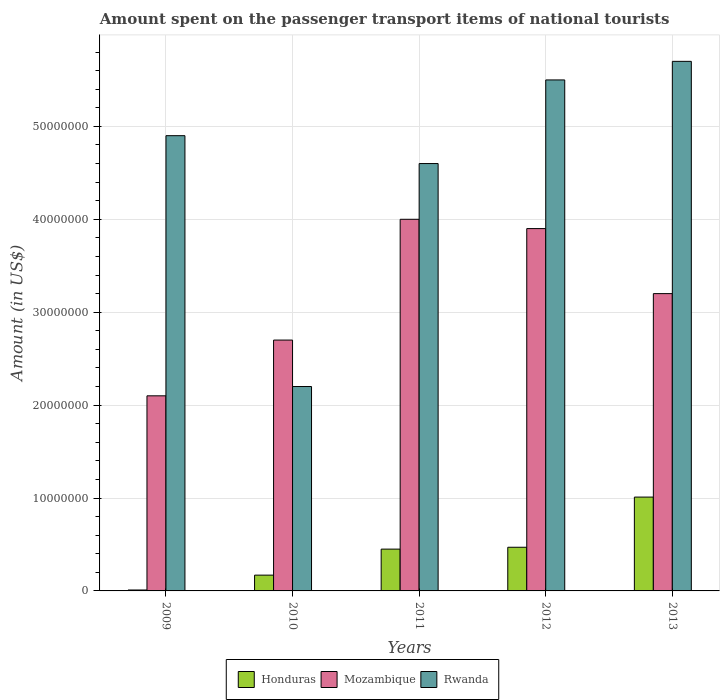How many different coloured bars are there?
Offer a terse response. 3. How many groups of bars are there?
Give a very brief answer. 5. Are the number of bars per tick equal to the number of legend labels?
Give a very brief answer. Yes. In how many cases, is the number of bars for a given year not equal to the number of legend labels?
Ensure brevity in your answer.  0. What is the amount spent on the passenger transport items of national tourists in Mozambique in 2011?
Offer a very short reply. 4.00e+07. Across all years, what is the maximum amount spent on the passenger transport items of national tourists in Mozambique?
Offer a very short reply. 4.00e+07. Across all years, what is the minimum amount spent on the passenger transport items of national tourists in Honduras?
Provide a short and direct response. 1.00e+05. What is the total amount spent on the passenger transport items of national tourists in Rwanda in the graph?
Offer a terse response. 2.29e+08. What is the difference between the amount spent on the passenger transport items of national tourists in Honduras in 2009 and that in 2010?
Ensure brevity in your answer.  -1.60e+06. What is the average amount spent on the passenger transport items of national tourists in Rwanda per year?
Your answer should be compact. 4.58e+07. In the year 2009, what is the difference between the amount spent on the passenger transport items of national tourists in Mozambique and amount spent on the passenger transport items of national tourists in Rwanda?
Your answer should be compact. -2.80e+07. What is the ratio of the amount spent on the passenger transport items of national tourists in Honduras in 2011 to that in 2012?
Give a very brief answer. 0.96. Is the amount spent on the passenger transport items of national tourists in Mozambique in 2010 less than that in 2011?
Your response must be concise. Yes. Is the difference between the amount spent on the passenger transport items of national tourists in Mozambique in 2009 and 2010 greater than the difference between the amount spent on the passenger transport items of national tourists in Rwanda in 2009 and 2010?
Your answer should be compact. No. What is the difference between the highest and the second highest amount spent on the passenger transport items of national tourists in Rwanda?
Your response must be concise. 2.00e+06. What is the difference between the highest and the lowest amount spent on the passenger transport items of national tourists in Rwanda?
Provide a short and direct response. 3.50e+07. In how many years, is the amount spent on the passenger transport items of national tourists in Honduras greater than the average amount spent on the passenger transport items of national tourists in Honduras taken over all years?
Offer a terse response. 3. What does the 3rd bar from the left in 2012 represents?
Offer a terse response. Rwanda. What does the 3rd bar from the right in 2011 represents?
Provide a short and direct response. Honduras. Is it the case that in every year, the sum of the amount spent on the passenger transport items of national tourists in Honduras and amount spent on the passenger transport items of national tourists in Rwanda is greater than the amount spent on the passenger transport items of national tourists in Mozambique?
Make the answer very short. No. What is the difference between two consecutive major ticks on the Y-axis?
Your answer should be compact. 1.00e+07. Are the values on the major ticks of Y-axis written in scientific E-notation?
Keep it short and to the point. No. What is the title of the graph?
Make the answer very short. Amount spent on the passenger transport items of national tourists. What is the label or title of the X-axis?
Your response must be concise. Years. What is the Amount (in US$) in Honduras in 2009?
Your answer should be compact. 1.00e+05. What is the Amount (in US$) in Mozambique in 2009?
Ensure brevity in your answer.  2.10e+07. What is the Amount (in US$) of Rwanda in 2009?
Give a very brief answer. 4.90e+07. What is the Amount (in US$) of Honduras in 2010?
Your answer should be compact. 1.70e+06. What is the Amount (in US$) in Mozambique in 2010?
Make the answer very short. 2.70e+07. What is the Amount (in US$) in Rwanda in 2010?
Give a very brief answer. 2.20e+07. What is the Amount (in US$) in Honduras in 2011?
Offer a terse response. 4.50e+06. What is the Amount (in US$) in Mozambique in 2011?
Keep it short and to the point. 4.00e+07. What is the Amount (in US$) of Rwanda in 2011?
Your answer should be compact. 4.60e+07. What is the Amount (in US$) in Honduras in 2012?
Your answer should be compact. 4.70e+06. What is the Amount (in US$) of Mozambique in 2012?
Give a very brief answer. 3.90e+07. What is the Amount (in US$) of Rwanda in 2012?
Offer a very short reply. 5.50e+07. What is the Amount (in US$) in Honduras in 2013?
Give a very brief answer. 1.01e+07. What is the Amount (in US$) of Mozambique in 2013?
Provide a succinct answer. 3.20e+07. What is the Amount (in US$) in Rwanda in 2013?
Offer a very short reply. 5.70e+07. Across all years, what is the maximum Amount (in US$) in Honduras?
Offer a very short reply. 1.01e+07. Across all years, what is the maximum Amount (in US$) of Mozambique?
Give a very brief answer. 4.00e+07. Across all years, what is the maximum Amount (in US$) of Rwanda?
Your answer should be compact. 5.70e+07. Across all years, what is the minimum Amount (in US$) in Honduras?
Your answer should be compact. 1.00e+05. Across all years, what is the minimum Amount (in US$) in Mozambique?
Offer a very short reply. 2.10e+07. Across all years, what is the minimum Amount (in US$) of Rwanda?
Your answer should be compact. 2.20e+07. What is the total Amount (in US$) of Honduras in the graph?
Make the answer very short. 2.11e+07. What is the total Amount (in US$) of Mozambique in the graph?
Ensure brevity in your answer.  1.59e+08. What is the total Amount (in US$) of Rwanda in the graph?
Offer a terse response. 2.29e+08. What is the difference between the Amount (in US$) in Honduras in 2009 and that in 2010?
Give a very brief answer. -1.60e+06. What is the difference between the Amount (in US$) of Mozambique in 2009 and that in 2010?
Give a very brief answer. -6.00e+06. What is the difference between the Amount (in US$) of Rwanda in 2009 and that in 2010?
Provide a short and direct response. 2.70e+07. What is the difference between the Amount (in US$) of Honduras in 2009 and that in 2011?
Keep it short and to the point. -4.40e+06. What is the difference between the Amount (in US$) of Mozambique in 2009 and that in 2011?
Your response must be concise. -1.90e+07. What is the difference between the Amount (in US$) in Honduras in 2009 and that in 2012?
Provide a succinct answer. -4.60e+06. What is the difference between the Amount (in US$) of Mozambique in 2009 and that in 2012?
Your answer should be very brief. -1.80e+07. What is the difference between the Amount (in US$) in Rwanda in 2009 and that in 2012?
Provide a succinct answer. -6.00e+06. What is the difference between the Amount (in US$) in Honduras in 2009 and that in 2013?
Offer a terse response. -1.00e+07. What is the difference between the Amount (in US$) in Mozambique in 2009 and that in 2013?
Make the answer very short. -1.10e+07. What is the difference between the Amount (in US$) of Rwanda in 2009 and that in 2013?
Keep it short and to the point. -8.00e+06. What is the difference between the Amount (in US$) of Honduras in 2010 and that in 2011?
Offer a very short reply. -2.80e+06. What is the difference between the Amount (in US$) of Mozambique in 2010 and that in 2011?
Make the answer very short. -1.30e+07. What is the difference between the Amount (in US$) in Rwanda in 2010 and that in 2011?
Your answer should be very brief. -2.40e+07. What is the difference between the Amount (in US$) in Honduras in 2010 and that in 2012?
Provide a short and direct response. -3.00e+06. What is the difference between the Amount (in US$) in Mozambique in 2010 and that in 2012?
Give a very brief answer. -1.20e+07. What is the difference between the Amount (in US$) of Rwanda in 2010 and that in 2012?
Give a very brief answer. -3.30e+07. What is the difference between the Amount (in US$) in Honduras in 2010 and that in 2013?
Your answer should be very brief. -8.40e+06. What is the difference between the Amount (in US$) in Mozambique in 2010 and that in 2013?
Give a very brief answer. -5.00e+06. What is the difference between the Amount (in US$) of Rwanda in 2010 and that in 2013?
Provide a succinct answer. -3.50e+07. What is the difference between the Amount (in US$) of Honduras in 2011 and that in 2012?
Keep it short and to the point. -2.00e+05. What is the difference between the Amount (in US$) in Mozambique in 2011 and that in 2012?
Ensure brevity in your answer.  1.00e+06. What is the difference between the Amount (in US$) in Rwanda in 2011 and that in 2012?
Offer a terse response. -9.00e+06. What is the difference between the Amount (in US$) in Honduras in 2011 and that in 2013?
Your answer should be very brief. -5.60e+06. What is the difference between the Amount (in US$) in Rwanda in 2011 and that in 2013?
Your answer should be very brief. -1.10e+07. What is the difference between the Amount (in US$) in Honduras in 2012 and that in 2013?
Your answer should be very brief. -5.40e+06. What is the difference between the Amount (in US$) in Mozambique in 2012 and that in 2013?
Provide a succinct answer. 7.00e+06. What is the difference between the Amount (in US$) in Honduras in 2009 and the Amount (in US$) in Mozambique in 2010?
Make the answer very short. -2.69e+07. What is the difference between the Amount (in US$) of Honduras in 2009 and the Amount (in US$) of Rwanda in 2010?
Offer a terse response. -2.19e+07. What is the difference between the Amount (in US$) in Honduras in 2009 and the Amount (in US$) in Mozambique in 2011?
Provide a short and direct response. -3.99e+07. What is the difference between the Amount (in US$) of Honduras in 2009 and the Amount (in US$) of Rwanda in 2011?
Provide a succinct answer. -4.59e+07. What is the difference between the Amount (in US$) in Mozambique in 2009 and the Amount (in US$) in Rwanda in 2011?
Offer a terse response. -2.50e+07. What is the difference between the Amount (in US$) in Honduras in 2009 and the Amount (in US$) in Mozambique in 2012?
Make the answer very short. -3.89e+07. What is the difference between the Amount (in US$) of Honduras in 2009 and the Amount (in US$) of Rwanda in 2012?
Keep it short and to the point. -5.49e+07. What is the difference between the Amount (in US$) of Mozambique in 2009 and the Amount (in US$) of Rwanda in 2012?
Make the answer very short. -3.40e+07. What is the difference between the Amount (in US$) of Honduras in 2009 and the Amount (in US$) of Mozambique in 2013?
Provide a succinct answer. -3.19e+07. What is the difference between the Amount (in US$) in Honduras in 2009 and the Amount (in US$) in Rwanda in 2013?
Your answer should be very brief. -5.69e+07. What is the difference between the Amount (in US$) of Mozambique in 2009 and the Amount (in US$) of Rwanda in 2013?
Offer a very short reply. -3.60e+07. What is the difference between the Amount (in US$) of Honduras in 2010 and the Amount (in US$) of Mozambique in 2011?
Your answer should be very brief. -3.83e+07. What is the difference between the Amount (in US$) in Honduras in 2010 and the Amount (in US$) in Rwanda in 2011?
Offer a very short reply. -4.43e+07. What is the difference between the Amount (in US$) of Mozambique in 2010 and the Amount (in US$) of Rwanda in 2011?
Offer a terse response. -1.90e+07. What is the difference between the Amount (in US$) of Honduras in 2010 and the Amount (in US$) of Mozambique in 2012?
Provide a succinct answer. -3.73e+07. What is the difference between the Amount (in US$) of Honduras in 2010 and the Amount (in US$) of Rwanda in 2012?
Offer a terse response. -5.33e+07. What is the difference between the Amount (in US$) in Mozambique in 2010 and the Amount (in US$) in Rwanda in 2012?
Offer a very short reply. -2.80e+07. What is the difference between the Amount (in US$) in Honduras in 2010 and the Amount (in US$) in Mozambique in 2013?
Offer a very short reply. -3.03e+07. What is the difference between the Amount (in US$) in Honduras in 2010 and the Amount (in US$) in Rwanda in 2013?
Your response must be concise. -5.53e+07. What is the difference between the Amount (in US$) of Mozambique in 2010 and the Amount (in US$) of Rwanda in 2013?
Your answer should be compact. -3.00e+07. What is the difference between the Amount (in US$) in Honduras in 2011 and the Amount (in US$) in Mozambique in 2012?
Give a very brief answer. -3.45e+07. What is the difference between the Amount (in US$) of Honduras in 2011 and the Amount (in US$) of Rwanda in 2012?
Your answer should be very brief. -5.05e+07. What is the difference between the Amount (in US$) in Mozambique in 2011 and the Amount (in US$) in Rwanda in 2012?
Your answer should be compact. -1.50e+07. What is the difference between the Amount (in US$) of Honduras in 2011 and the Amount (in US$) of Mozambique in 2013?
Offer a terse response. -2.75e+07. What is the difference between the Amount (in US$) in Honduras in 2011 and the Amount (in US$) in Rwanda in 2013?
Make the answer very short. -5.25e+07. What is the difference between the Amount (in US$) of Mozambique in 2011 and the Amount (in US$) of Rwanda in 2013?
Ensure brevity in your answer.  -1.70e+07. What is the difference between the Amount (in US$) of Honduras in 2012 and the Amount (in US$) of Mozambique in 2013?
Provide a short and direct response. -2.73e+07. What is the difference between the Amount (in US$) in Honduras in 2012 and the Amount (in US$) in Rwanda in 2013?
Offer a terse response. -5.23e+07. What is the difference between the Amount (in US$) of Mozambique in 2012 and the Amount (in US$) of Rwanda in 2013?
Keep it short and to the point. -1.80e+07. What is the average Amount (in US$) of Honduras per year?
Provide a succinct answer. 4.22e+06. What is the average Amount (in US$) of Mozambique per year?
Your answer should be compact. 3.18e+07. What is the average Amount (in US$) of Rwanda per year?
Your answer should be very brief. 4.58e+07. In the year 2009, what is the difference between the Amount (in US$) of Honduras and Amount (in US$) of Mozambique?
Offer a terse response. -2.09e+07. In the year 2009, what is the difference between the Amount (in US$) in Honduras and Amount (in US$) in Rwanda?
Ensure brevity in your answer.  -4.89e+07. In the year 2009, what is the difference between the Amount (in US$) in Mozambique and Amount (in US$) in Rwanda?
Give a very brief answer. -2.80e+07. In the year 2010, what is the difference between the Amount (in US$) of Honduras and Amount (in US$) of Mozambique?
Provide a short and direct response. -2.53e+07. In the year 2010, what is the difference between the Amount (in US$) in Honduras and Amount (in US$) in Rwanda?
Give a very brief answer. -2.03e+07. In the year 2010, what is the difference between the Amount (in US$) of Mozambique and Amount (in US$) of Rwanda?
Provide a succinct answer. 5.00e+06. In the year 2011, what is the difference between the Amount (in US$) in Honduras and Amount (in US$) in Mozambique?
Offer a very short reply. -3.55e+07. In the year 2011, what is the difference between the Amount (in US$) in Honduras and Amount (in US$) in Rwanda?
Your answer should be compact. -4.15e+07. In the year 2011, what is the difference between the Amount (in US$) of Mozambique and Amount (in US$) of Rwanda?
Provide a short and direct response. -6.00e+06. In the year 2012, what is the difference between the Amount (in US$) in Honduras and Amount (in US$) in Mozambique?
Ensure brevity in your answer.  -3.43e+07. In the year 2012, what is the difference between the Amount (in US$) of Honduras and Amount (in US$) of Rwanda?
Provide a succinct answer. -5.03e+07. In the year 2012, what is the difference between the Amount (in US$) of Mozambique and Amount (in US$) of Rwanda?
Give a very brief answer. -1.60e+07. In the year 2013, what is the difference between the Amount (in US$) of Honduras and Amount (in US$) of Mozambique?
Your answer should be very brief. -2.19e+07. In the year 2013, what is the difference between the Amount (in US$) in Honduras and Amount (in US$) in Rwanda?
Your response must be concise. -4.69e+07. In the year 2013, what is the difference between the Amount (in US$) in Mozambique and Amount (in US$) in Rwanda?
Make the answer very short. -2.50e+07. What is the ratio of the Amount (in US$) of Honduras in 2009 to that in 2010?
Provide a short and direct response. 0.06. What is the ratio of the Amount (in US$) in Rwanda in 2009 to that in 2010?
Offer a very short reply. 2.23. What is the ratio of the Amount (in US$) of Honduras in 2009 to that in 2011?
Your answer should be compact. 0.02. What is the ratio of the Amount (in US$) of Mozambique in 2009 to that in 2011?
Provide a short and direct response. 0.53. What is the ratio of the Amount (in US$) in Rwanda in 2009 to that in 2011?
Provide a short and direct response. 1.07. What is the ratio of the Amount (in US$) of Honduras in 2009 to that in 2012?
Keep it short and to the point. 0.02. What is the ratio of the Amount (in US$) of Mozambique in 2009 to that in 2012?
Your answer should be very brief. 0.54. What is the ratio of the Amount (in US$) of Rwanda in 2009 to that in 2012?
Your answer should be compact. 0.89. What is the ratio of the Amount (in US$) in Honduras in 2009 to that in 2013?
Your answer should be very brief. 0.01. What is the ratio of the Amount (in US$) in Mozambique in 2009 to that in 2013?
Give a very brief answer. 0.66. What is the ratio of the Amount (in US$) in Rwanda in 2009 to that in 2013?
Your response must be concise. 0.86. What is the ratio of the Amount (in US$) in Honduras in 2010 to that in 2011?
Provide a succinct answer. 0.38. What is the ratio of the Amount (in US$) in Mozambique in 2010 to that in 2011?
Your answer should be very brief. 0.68. What is the ratio of the Amount (in US$) of Rwanda in 2010 to that in 2011?
Keep it short and to the point. 0.48. What is the ratio of the Amount (in US$) of Honduras in 2010 to that in 2012?
Provide a succinct answer. 0.36. What is the ratio of the Amount (in US$) in Mozambique in 2010 to that in 2012?
Give a very brief answer. 0.69. What is the ratio of the Amount (in US$) in Rwanda in 2010 to that in 2012?
Your answer should be compact. 0.4. What is the ratio of the Amount (in US$) in Honduras in 2010 to that in 2013?
Ensure brevity in your answer.  0.17. What is the ratio of the Amount (in US$) in Mozambique in 2010 to that in 2013?
Offer a terse response. 0.84. What is the ratio of the Amount (in US$) of Rwanda in 2010 to that in 2013?
Offer a terse response. 0.39. What is the ratio of the Amount (in US$) of Honduras in 2011 to that in 2012?
Make the answer very short. 0.96. What is the ratio of the Amount (in US$) in Mozambique in 2011 to that in 2012?
Ensure brevity in your answer.  1.03. What is the ratio of the Amount (in US$) in Rwanda in 2011 to that in 2012?
Make the answer very short. 0.84. What is the ratio of the Amount (in US$) in Honduras in 2011 to that in 2013?
Your response must be concise. 0.45. What is the ratio of the Amount (in US$) of Mozambique in 2011 to that in 2013?
Your response must be concise. 1.25. What is the ratio of the Amount (in US$) of Rwanda in 2011 to that in 2013?
Keep it short and to the point. 0.81. What is the ratio of the Amount (in US$) in Honduras in 2012 to that in 2013?
Keep it short and to the point. 0.47. What is the ratio of the Amount (in US$) in Mozambique in 2012 to that in 2013?
Keep it short and to the point. 1.22. What is the ratio of the Amount (in US$) of Rwanda in 2012 to that in 2013?
Give a very brief answer. 0.96. What is the difference between the highest and the second highest Amount (in US$) of Honduras?
Provide a short and direct response. 5.40e+06. What is the difference between the highest and the second highest Amount (in US$) in Mozambique?
Your answer should be very brief. 1.00e+06. What is the difference between the highest and the second highest Amount (in US$) in Rwanda?
Offer a very short reply. 2.00e+06. What is the difference between the highest and the lowest Amount (in US$) of Mozambique?
Provide a succinct answer. 1.90e+07. What is the difference between the highest and the lowest Amount (in US$) of Rwanda?
Give a very brief answer. 3.50e+07. 